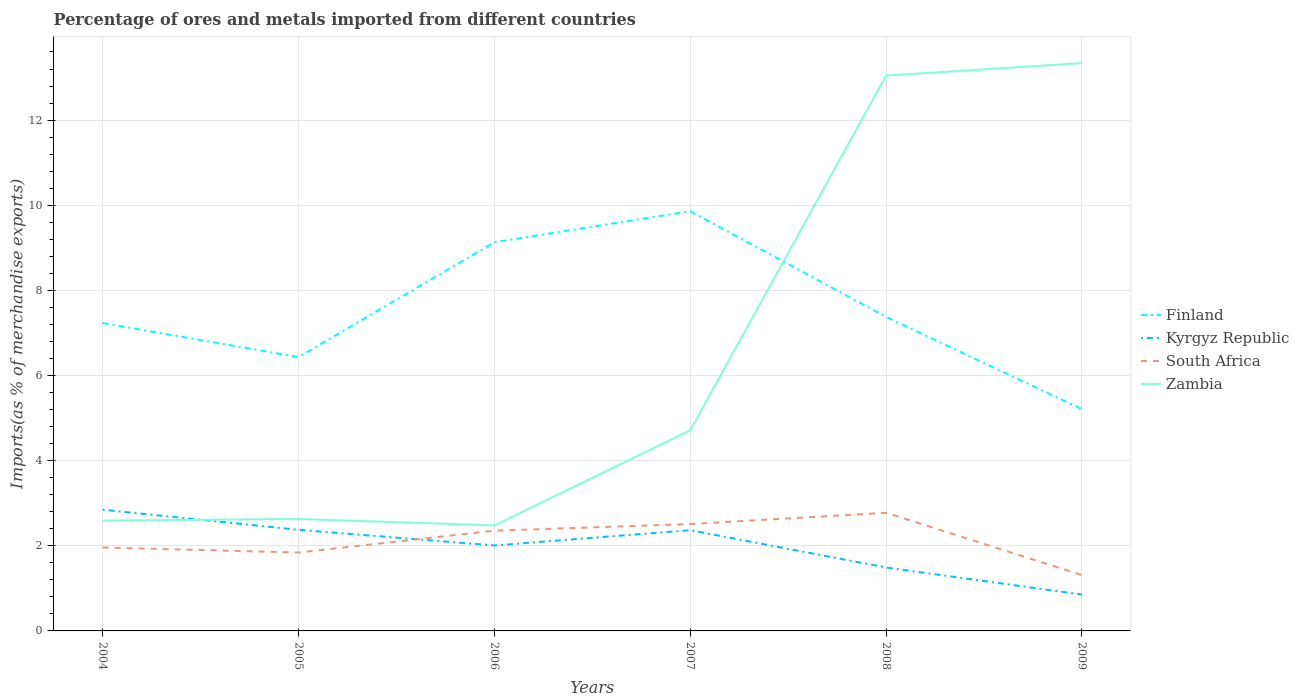Across all years, what is the maximum percentage of imports to different countries in Zambia?
Your answer should be very brief. 2.48. In which year was the percentage of imports to different countries in Kyrgyz Republic maximum?
Keep it short and to the point. 2009. What is the total percentage of imports to different countries in Zambia in the graph?
Your answer should be compact. -2.08. What is the difference between the highest and the second highest percentage of imports to different countries in Kyrgyz Republic?
Make the answer very short. 1.99. What is the difference between the highest and the lowest percentage of imports to different countries in South Africa?
Make the answer very short. 3. Is the percentage of imports to different countries in Finland strictly greater than the percentage of imports to different countries in Zambia over the years?
Give a very brief answer. No. How many lines are there?
Your answer should be very brief. 4. How many years are there in the graph?
Make the answer very short. 6. Are the values on the major ticks of Y-axis written in scientific E-notation?
Make the answer very short. No. How many legend labels are there?
Your response must be concise. 4. What is the title of the graph?
Your answer should be compact. Percentage of ores and metals imported from different countries. What is the label or title of the Y-axis?
Your response must be concise. Imports(as % of merchandise exports). What is the Imports(as % of merchandise exports) in Finland in 2004?
Provide a short and direct response. 7.23. What is the Imports(as % of merchandise exports) in Kyrgyz Republic in 2004?
Make the answer very short. 2.85. What is the Imports(as % of merchandise exports) of South Africa in 2004?
Ensure brevity in your answer.  1.96. What is the Imports(as % of merchandise exports) in Zambia in 2004?
Make the answer very short. 2.59. What is the Imports(as % of merchandise exports) of Finland in 2005?
Your answer should be compact. 6.43. What is the Imports(as % of merchandise exports) of Kyrgyz Republic in 2005?
Provide a short and direct response. 2.37. What is the Imports(as % of merchandise exports) in South Africa in 2005?
Offer a very short reply. 1.84. What is the Imports(as % of merchandise exports) of Zambia in 2005?
Provide a succinct answer. 2.63. What is the Imports(as % of merchandise exports) of Finland in 2006?
Your answer should be very brief. 9.13. What is the Imports(as % of merchandise exports) in Kyrgyz Republic in 2006?
Offer a terse response. 2.01. What is the Imports(as % of merchandise exports) in South Africa in 2006?
Keep it short and to the point. 2.35. What is the Imports(as % of merchandise exports) in Zambia in 2006?
Offer a terse response. 2.48. What is the Imports(as % of merchandise exports) of Finland in 2007?
Offer a very short reply. 9.86. What is the Imports(as % of merchandise exports) of Kyrgyz Republic in 2007?
Keep it short and to the point. 2.37. What is the Imports(as % of merchandise exports) of South Africa in 2007?
Offer a terse response. 2.51. What is the Imports(as % of merchandise exports) of Zambia in 2007?
Keep it short and to the point. 4.71. What is the Imports(as % of merchandise exports) of Finland in 2008?
Your answer should be compact. 7.38. What is the Imports(as % of merchandise exports) in Kyrgyz Republic in 2008?
Your response must be concise. 1.49. What is the Imports(as % of merchandise exports) in South Africa in 2008?
Your answer should be very brief. 2.78. What is the Imports(as % of merchandise exports) in Zambia in 2008?
Make the answer very short. 13.05. What is the Imports(as % of merchandise exports) of Finland in 2009?
Provide a succinct answer. 5.21. What is the Imports(as % of merchandise exports) in Kyrgyz Republic in 2009?
Your answer should be very brief. 0.85. What is the Imports(as % of merchandise exports) in South Africa in 2009?
Provide a short and direct response. 1.31. What is the Imports(as % of merchandise exports) of Zambia in 2009?
Your answer should be very brief. 13.34. Across all years, what is the maximum Imports(as % of merchandise exports) of Finland?
Provide a short and direct response. 9.86. Across all years, what is the maximum Imports(as % of merchandise exports) in Kyrgyz Republic?
Provide a succinct answer. 2.85. Across all years, what is the maximum Imports(as % of merchandise exports) in South Africa?
Keep it short and to the point. 2.78. Across all years, what is the maximum Imports(as % of merchandise exports) in Zambia?
Offer a terse response. 13.34. Across all years, what is the minimum Imports(as % of merchandise exports) of Finland?
Your response must be concise. 5.21. Across all years, what is the minimum Imports(as % of merchandise exports) in Kyrgyz Republic?
Make the answer very short. 0.85. Across all years, what is the minimum Imports(as % of merchandise exports) in South Africa?
Make the answer very short. 1.31. Across all years, what is the minimum Imports(as % of merchandise exports) of Zambia?
Your response must be concise. 2.48. What is the total Imports(as % of merchandise exports) of Finland in the graph?
Your answer should be very brief. 45.24. What is the total Imports(as % of merchandise exports) in Kyrgyz Republic in the graph?
Provide a succinct answer. 11.94. What is the total Imports(as % of merchandise exports) of South Africa in the graph?
Provide a short and direct response. 12.75. What is the total Imports(as % of merchandise exports) of Zambia in the graph?
Provide a short and direct response. 38.8. What is the difference between the Imports(as % of merchandise exports) of Finland in 2004 and that in 2005?
Make the answer very short. 0.8. What is the difference between the Imports(as % of merchandise exports) in Kyrgyz Republic in 2004 and that in 2005?
Offer a terse response. 0.47. What is the difference between the Imports(as % of merchandise exports) in South Africa in 2004 and that in 2005?
Keep it short and to the point. 0.12. What is the difference between the Imports(as % of merchandise exports) of Zambia in 2004 and that in 2005?
Provide a short and direct response. -0.04. What is the difference between the Imports(as % of merchandise exports) of Finland in 2004 and that in 2006?
Ensure brevity in your answer.  -1.9. What is the difference between the Imports(as % of merchandise exports) in Kyrgyz Republic in 2004 and that in 2006?
Keep it short and to the point. 0.84. What is the difference between the Imports(as % of merchandise exports) of South Africa in 2004 and that in 2006?
Your answer should be very brief. -0.4. What is the difference between the Imports(as % of merchandise exports) in Zambia in 2004 and that in 2006?
Your answer should be very brief. 0.11. What is the difference between the Imports(as % of merchandise exports) of Finland in 2004 and that in 2007?
Ensure brevity in your answer.  -2.63. What is the difference between the Imports(as % of merchandise exports) in Kyrgyz Republic in 2004 and that in 2007?
Provide a short and direct response. 0.48. What is the difference between the Imports(as % of merchandise exports) in South Africa in 2004 and that in 2007?
Your response must be concise. -0.55. What is the difference between the Imports(as % of merchandise exports) of Zambia in 2004 and that in 2007?
Your answer should be very brief. -2.12. What is the difference between the Imports(as % of merchandise exports) of Finland in 2004 and that in 2008?
Make the answer very short. -0.14. What is the difference between the Imports(as % of merchandise exports) in Kyrgyz Republic in 2004 and that in 2008?
Keep it short and to the point. 1.36. What is the difference between the Imports(as % of merchandise exports) of South Africa in 2004 and that in 2008?
Offer a terse response. -0.82. What is the difference between the Imports(as % of merchandise exports) of Zambia in 2004 and that in 2008?
Keep it short and to the point. -10.46. What is the difference between the Imports(as % of merchandise exports) of Finland in 2004 and that in 2009?
Offer a very short reply. 2.02. What is the difference between the Imports(as % of merchandise exports) in Kyrgyz Republic in 2004 and that in 2009?
Ensure brevity in your answer.  1.99. What is the difference between the Imports(as % of merchandise exports) of South Africa in 2004 and that in 2009?
Your response must be concise. 0.65. What is the difference between the Imports(as % of merchandise exports) of Zambia in 2004 and that in 2009?
Keep it short and to the point. -10.75. What is the difference between the Imports(as % of merchandise exports) in Finland in 2005 and that in 2006?
Your answer should be compact. -2.7. What is the difference between the Imports(as % of merchandise exports) of Kyrgyz Republic in 2005 and that in 2006?
Make the answer very short. 0.37. What is the difference between the Imports(as % of merchandise exports) in South Africa in 2005 and that in 2006?
Offer a terse response. -0.51. What is the difference between the Imports(as % of merchandise exports) in Zambia in 2005 and that in 2006?
Your answer should be compact. 0.15. What is the difference between the Imports(as % of merchandise exports) in Finland in 2005 and that in 2007?
Make the answer very short. -3.43. What is the difference between the Imports(as % of merchandise exports) of Kyrgyz Republic in 2005 and that in 2007?
Offer a terse response. 0.01. What is the difference between the Imports(as % of merchandise exports) of South Africa in 2005 and that in 2007?
Provide a succinct answer. -0.67. What is the difference between the Imports(as % of merchandise exports) in Zambia in 2005 and that in 2007?
Keep it short and to the point. -2.08. What is the difference between the Imports(as % of merchandise exports) of Finland in 2005 and that in 2008?
Make the answer very short. -0.94. What is the difference between the Imports(as % of merchandise exports) of Kyrgyz Republic in 2005 and that in 2008?
Offer a terse response. 0.89. What is the difference between the Imports(as % of merchandise exports) of South Africa in 2005 and that in 2008?
Ensure brevity in your answer.  -0.93. What is the difference between the Imports(as % of merchandise exports) in Zambia in 2005 and that in 2008?
Ensure brevity in your answer.  -10.42. What is the difference between the Imports(as % of merchandise exports) in Finland in 2005 and that in 2009?
Provide a succinct answer. 1.22. What is the difference between the Imports(as % of merchandise exports) of Kyrgyz Republic in 2005 and that in 2009?
Keep it short and to the point. 1.52. What is the difference between the Imports(as % of merchandise exports) of South Africa in 2005 and that in 2009?
Make the answer very short. 0.53. What is the difference between the Imports(as % of merchandise exports) in Zambia in 2005 and that in 2009?
Give a very brief answer. -10.71. What is the difference between the Imports(as % of merchandise exports) of Finland in 2006 and that in 2007?
Keep it short and to the point. -0.73. What is the difference between the Imports(as % of merchandise exports) of Kyrgyz Republic in 2006 and that in 2007?
Your answer should be very brief. -0.36. What is the difference between the Imports(as % of merchandise exports) of South Africa in 2006 and that in 2007?
Your answer should be compact. -0.16. What is the difference between the Imports(as % of merchandise exports) of Zambia in 2006 and that in 2007?
Provide a short and direct response. -2.23. What is the difference between the Imports(as % of merchandise exports) in Finland in 2006 and that in 2008?
Ensure brevity in your answer.  1.75. What is the difference between the Imports(as % of merchandise exports) in Kyrgyz Republic in 2006 and that in 2008?
Ensure brevity in your answer.  0.52. What is the difference between the Imports(as % of merchandise exports) of South Africa in 2006 and that in 2008?
Provide a short and direct response. -0.42. What is the difference between the Imports(as % of merchandise exports) of Zambia in 2006 and that in 2008?
Provide a succinct answer. -10.57. What is the difference between the Imports(as % of merchandise exports) in Finland in 2006 and that in 2009?
Your answer should be compact. 3.92. What is the difference between the Imports(as % of merchandise exports) of Kyrgyz Republic in 2006 and that in 2009?
Make the answer very short. 1.15. What is the difference between the Imports(as % of merchandise exports) of South Africa in 2006 and that in 2009?
Keep it short and to the point. 1.04. What is the difference between the Imports(as % of merchandise exports) in Zambia in 2006 and that in 2009?
Offer a very short reply. -10.86. What is the difference between the Imports(as % of merchandise exports) of Finland in 2007 and that in 2008?
Make the answer very short. 2.48. What is the difference between the Imports(as % of merchandise exports) of Kyrgyz Republic in 2007 and that in 2008?
Provide a short and direct response. 0.88. What is the difference between the Imports(as % of merchandise exports) in South Africa in 2007 and that in 2008?
Your response must be concise. -0.27. What is the difference between the Imports(as % of merchandise exports) of Zambia in 2007 and that in 2008?
Offer a very short reply. -8.33. What is the difference between the Imports(as % of merchandise exports) of Finland in 2007 and that in 2009?
Provide a succinct answer. 4.65. What is the difference between the Imports(as % of merchandise exports) in Kyrgyz Republic in 2007 and that in 2009?
Give a very brief answer. 1.51. What is the difference between the Imports(as % of merchandise exports) in South Africa in 2007 and that in 2009?
Your answer should be very brief. 1.2. What is the difference between the Imports(as % of merchandise exports) of Zambia in 2007 and that in 2009?
Provide a short and direct response. -8.63. What is the difference between the Imports(as % of merchandise exports) in Finland in 2008 and that in 2009?
Offer a terse response. 2.17. What is the difference between the Imports(as % of merchandise exports) of Kyrgyz Republic in 2008 and that in 2009?
Provide a short and direct response. 0.64. What is the difference between the Imports(as % of merchandise exports) in South Africa in 2008 and that in 2009?
Provide a short and direct response. 1.46. What is the difference between the Imports(as % of merchandise exports) of Zambia in 2008 and that in 2009?
Ensure brevity in your answer.  -0.29. What is the difference between the Imports(as % of merchandise exports) in Finland in 2004 and the Imports(as % of merchandise exports) in Kyrgyz Republic in 2005?
Your answer should be very brief. 4.86. What is the difference between the Imports(as % of merchandise exports) of Finland in 2004 and the Imports(as % of merchandise exports) of South Africa in 2005?
Provide a succinct answer. 5.39. What is the difference between the Imports(as % of merchandise exports) of Finland in 2004 and the Imports(as % of merchandise exports) of Zambia in 2005?
Make the answer very short. 4.6. What is the difference between the Imports(as % of merchandise exports) of Kyrgyz Republic in 2004 and the Imports(as % of merchandise exports) of Zambia in 2005?
Keep it short and to the point. 0.22. What is the difference between the Imports(as % of merchandise exports) of South Africa in 2004 and the Imports(as % of merchandise exports) of Zambia in 2005?
Offer a terse response. -0.67. What is the difference between the Imports(as % of merchandise exports) in Finland in 2004 and the Imports(as % of merchandise exports) in Kyrgyz Republic in 2006?
Ensure brevity in your answer.  5.22. What is the difference between the Imports(as % of merchandise exports) of Finland in 2004 and the Imports(as % of merchandise exports) of South Africa in 2006?
Keep it short and to the point. 4.88. What is the difference between the Imports(as % of merchandise exports) of Finland in 2004 and the Imports(as % of merchandise exports) of Zambia in 2006?
Your response must be concise. 4.75. What is the difference between the Imports(as % of merchandise exports) in Kyrgyz Republic in 2004 and the Imports(as % of merchandise exports) in South Africa in 2006?
Provide a succinct answer. 0.49. What is the difference between the Imports(as % of merchandise exports) of Kyrgyz Republic in 2004 and the Imports(as % of merchandise exports) of Zambia in 2006?
Offer a terse response. 0.37. What is the difference between the Imports(as % of merchandise exports) of South Africa in 2004 and the Imports(as % of merchandise exports) of Zambia in 2006?
Make the answer very short. -0.52. What is the difference between the Imports(as % of merchandise exports) in Finland in 2004 and the Imports(as % of merchandise exports) in Kyrgyz Republic in 2007?
Provide a succinct answer. 4.87. What is the difference between the Imports(as % of merchandise exports) in Finland in 2004 and the Imports(as % of merchandise exports) in South Africa in 2007?
Make the answer very short. 4.72. What is the difference between the Imports(as % of merchandise exports) of Finland in 2004 and the Imports(as % of merchandise exports) of Zambia in 2007?
Provide a short and direct response. 2.52. What is the difference between the Imports(as % of merchandise exports) in Kyrgyz Republic in 2004 and the Imports(as % of merchandise exports) in South Africa in 2007?
Make the answer very short. 0.34. What is the difference between the Imports(as % of merchandise exports) in Kyrgyz Republic in 2004 and the Imports(as % of merchandise exports) in Zambia in 2007?
Make the answer very short. -1.86. What is the difference between the Imports(as % of merchandise exports) of South Africa in 2004 and the Imports(as % of merchandise exports) of Zambia in 2007?
Your answer should be very brief. -2.75. What is the difference between the Imports(as % of merchandise exports) of Finland in 2004 and the Imports(as % of merchandise exports) of Kyrgyz Republic in 2008?
Make the answer very short. 5.74. What is the difference between the Imports(as % of merchandise exports) of Finland in 2004 and the Imports(as % of merchandise exports) of South Africa in 2008?
Give a very brief answer. 4.46. What is the difference between the Imports(as % of merchandise exports) in Finland in 2004 and the Imports(as % of merchandise exports) in Zambia in 2008?
Your response must be concise. -5.81. What is the difference between the Imports(as % of merchandise exports) in Kyrgyz Republic in 2004 and the Imports(as % of merchandise exports) in South Africa in 2008?
Offer a very short reply. 0.07. What is the difference between the Imports(as % of merchandise exports) of Kyrgyz Republic in 2004 and the Imports(as % of merchandise exports) of Zambia in 2008?
Offer a very short reply. -10.2. What is the difference between the Imports(as % of merchandise exports) of South Africa in 2004 and the Imports(as % of merchandise exports) of Zambia in 2008?
Keep it short and to the point. -11.09. What is the difference between the Imports(as % of merchandise exports) in Finland in 2004 and the Imports(as % of merchandise exports) in Kyrgyz Republic in 2009?
Give a very brief answer. 6.38. What is the difference between the Imports(as % of merchandise exports) in Finland in 2004 and the Imports(as % of merchandise exports) in South Africa in 2009?
Ensure brevity in your answer.  5.92. What is the difference between the Imports(as % of merchandise exports) of Finland in 2004 and the Imports(as % of merchandise exports) of Zambia in 2009?
Provide a succinct answer. -6.11. What is the difference between the Imports(as % of merchandise exports) in Kyrgyz Republic in 2004 and the Imports(as % of merchandise exports) in South Africa in 2009?
Offer a very short reply. 1.54. What is the difference between the Imports(as % of merchandise exports) of Kyrgyz Republic in 2004 and the Imports(as % of merchandise exports) of Zambia in 2009?
Make the answer very short. -10.49. What is the difference between the Imports(as % of merchandise exports) in South Africa in 2004 and the Imports(as % of merchandise exports) in Zambia in 2009?
Give a very brief answer. -11.38. What is the difference between the Imports(as % of merchandise exports) of Finland in 2005 and the Imports(as % of merchandise exports) of Kyrgyz Republic in 2006?
Make the answer very short. 4.43. What is the difference between the Imports(as % of merchandise exports) of Finland in 2005 and the Imports(as % of merchandise exports) of South Africa in 2006?
Offer a terse response. 4.08. What is the difference between the Imports(as % of merchandise exports) of Finland in 2005 and the Imports(as % of merchandise exports) of Zambia in 2006?
Your answer should be compact. 3.95. What is the difference between the Imports(as % of merchandise exports) of Kyrgyz Republic in 2005 and the Imports(as % of merchandise exports) of South Africa in 2006?
Offer a very short reply. 0.02. What is the difference between the Imports(as % of merchandise exports) in Kyrgyz Republic in 2005 and the Imports(as % of merchandise exports) in Zambia in 2006?
Keep it short and to the point. -0.1. What is the difference between the Imports(as % of merchandise exports) in South Africa in 2005 and the Imports(as % of merchandise exports) in Zambia in 2006?
Provide a succinct answer. -0.64. What is the difference between the Imports(as % of merchandise exports) of Finland in 2005 and the Imports(as % of merchandise exports) of Kyrgyz Republic in 2007?
Offer a terse response. 4.07. What is the difference between the Imports(as % of merchandise exports) of Finland in 2005 and the Imports(as % of merchandise exports) of South Africa in 2007?
Provide a short and direct response. 3.92. What is the difference between the Imports(as % of merchandise exports) of Finland in 2005 and the Imports(as % of merchandise exports) of Zambia in 2007?
Provide a short and direct response. 1.72. What is the difference between the Imports(as % of merchandise exports) in Kyrgyz Republic in 2005 and the Imports(as % of merchandise exports) in South Africa in 2007?
Your answer should be compact. -0.14. What is the difference between the Imports(as % of merchandise exports) in Kyrgyz Republic in 2005 and the Imports(as % of merchandise exports) in Zambia in 2007?
Provide a succinct answer. -2.34. What is the difference between the Imports(as % of merchandise exports) in South Africa in 2005 and the Imports(as % of merchandise exports) in Zambia in 2007?
Make the answer very short. -2.87. What is the difference between the Imports(as % of merchandise exports) of Finland in 2005 and the Imports(as % of merchandise exports) of Kyrgyz Republic in 2008?
Offer a very short reply. 4.94. What is the difference between the Imports(as % of merchandise exports) in Finland in 2005 and the Imports(as % of merchandise exports) in South Africa in 2008?
Ensure brevity in your answer.  3.66. What is the difference between the Imports(as % of merchandise exports) of Finland in 2005 and the Imports(as % of merchandise exports) of Zambia in 2008?
Offer a very short reply. -6.61. What is the difference between the Imports(as % of merchandise exports) of Kyrgyz Republic in 2005 and the Imports(as % of merchandise exports) of South Africa in 2008?
Your answer should be compact. -0.4. What is the difference between the Imports(as % of merchandise exports) in Kyrgyz Republic in 2005 and the Imports(as % of merchandise exports) in Zambia in 2008?
Provide a succinct answer. -10.67. What is the difference between the Imports(as % of merchandise exports) of South Africa in 2005 and the Imports(as % of merchandise exports) of Zambia in 2008?
Offer a terse response. -11.2. What is the difference between the Imports(as % of merchandise exports) in Finland in 2005 and the Imports(as % of merchandise exports) in Kyrgyz Republic in 2009?
Offer a terse response. 5.58. What is the difference between the Imports(as % of merchandise exports) of Finland in 2005 and the Imports(as % of merchandise exports) of South Africa in 2009?
Provide a short and direct response. 5.12. What is the difference between the Imports(as % of merchandise exports) in Finland in 2005 and the Imports(as % of merchandise exports) in Zambia in 2009?
Make the answer very short. -6.9. What is the difference between the Imports(as % of merchandise exports) in Kyrgyz Republic in 2005 and the Imports(as % of merchandise exports) in South Africa in 2009?
Your response must be concise. 1.06. What is the difference between the Imports(as % of merchandise exports) in Kyrgyz Republic in 2005 and the Imports(as % of merchandise exports) in Zambia in 2009?
Offer a terse response. -10.96. What is the difference between the Imports(as % of merchandise exports) in South Africa in 2005 and the Imports(as % of merchandise exports) in Zambia in 2009?
Provide a short and direct response. -11.5. What is the difference between the Imports(as % of merchandise exports) in Finland in 2006 and the Imports(as % of merchandise exports) in Kyrgyz Republic in 2007?
Your response must be concise. 6.76. What is the difference between the Imports(as % of merchandise exports) of Finland in 2006 and the Imports(as % of merchandise exports) of South Africa in 2007?
Provide a short and direct response. 6.62. What is the difference between the Imports(as % of merchandise exports) of Finland in 2006 and the Imports(as % of merchandise exports) of Zambia in 2007?
Offer a terse response. 4.42. What is the difference between the Imports(as % of merchandise exports) of Kyrgyz Republic in 2006 and the Imports(as % of merchandise exports) of South Africa in 2007?
Provide a succinct answer. -0.5. What is the difference between the Imports(as % of merchandise exports) of Kyrgyz Republic in 2006 and the Imports(as % of merchandise exports) of Zambia in 2007?
Give a very brief answer. -2.7. What is the difference between the Imports(as % of merchandise exports) of South Africa in 2006 and the Imports(as % of merchandise exports) of Zambia in 2007?
Provide a short and direct response. -2.36. What is the difference between the Imports(as % of merchandise exports) in Finland in 2006 and the Imports(as % of merchandise exports) in Kyrgyz Republic in 2008?
Offer a terse response. 7.64. What is the difference between the Imports(as % of merchandise exports) of Finland in 2006 and the Imports(as % of merchandise exports) of South Africa in 2008?
Provide a succinct answer. 6.36. What is the difference between the Imports(as % of merchandise exports) in Finland in 2006 and the Imports(as % of merchandise exports) in Zambia in 2008?
Offer a very short reply. -3.91. What is the difference between the Imports(as % of merchandise exports) in Kyrgyz Republic in 2006 and the Imports(as % of merchandise exports) in South Africa in 2008?
Offer a terse response. -0.77. What is the difference between the Imports(as % of merchandise exports) of Kyrgyz Republic in 2006 and the Imports(as % of merchandise exports) of Zambia in 2008?
Ensure brevity in your answer.  -11.04. What is the difference between the Imports(as % of merchandise exports) in South Africa in 2006 and the Imports(as % of merchandise exports) in Zambia in 2008?
Your answer should be very brief. -10.69. What is the difference between the Imports(as % of merchandise exports) of Finland in 2006 and the Imports(as % of merchandise exports) of Kyrgyz Republic in 2009?
Offer a terse response. 8.28. What is the difference between the Imports(as % of merchandise exports) of Finland in 2006 and the Imports(as % of merchandise exports) of South Africa in 2009?
Make the answer very short. 7.82. What is the difference between the Imports(as % of merchandise exports) of Finland in 2006 and the Imports(as % of merchandise exports) of Zambia in 2009?
Your answer should be compact. -4.21. What is the difference between the Imports(as % of merchandise exports) of Kyrgyz Republic in 2006 and the Imports(as % of merchandise exports) of South Africa in 2009?
Provide a short and direct response. 0.7. What is the difference between the Imports(as % of merchandise exports) in Kyrgyz Republic in 2006 and the Imports(as % of merchandise exports) in Zambia in 2009?
Your answer should be compact. -11.33. What is the difference between the Imports(as % of merchandise exports) in South Africa in 2006 and the Imports(as % of merchandise exports) in Zambia in 2009?
Ensure brevity in your answer.  -10.98. What is the difference between the Imports(as % of merchandise exports) of Finland in 2007 and the Imports(as % of merchandise exports) of Kyrgyz Republic in 2008?
Provide a short and direct response. 8.37. What is the difference between the Imports(as % of merchandise exports) of Finland in 2007 and the Imports(as % of merchandise exports) of South Africa in 2008?
Provide a short and direct response. 7.08. What is the difference between the Imports(as % of merchandise exports) in Finland in 2007 and the Imports(as % of merchandise exports) in Zambia in 2008?
Keep it short and to the point. -3.19. What is the difference between the Imports(as % of merchandise exports) of Kyrgyz Republic in 2007 and the Imports(as % of merchandise exports) of South Africa in 2008?
Offer a very short reply. -0.41. What is the difference between the Imports(as % of merchandise exports) of Kyrgyz Republic in 2007 and the Imports(as % of merchandise exports) of Zambia in 2008?
Your answer should be compact. -10.68. What is the difference between the Imports(as % of merchandise exports) in South Africa in 2007 and the Imports(as % of merchandise exports) in Zambia in 2008?
Give a very brief answer. -10.54. What is the difference between the Imports(as % of merchandise exports) of Finland in 2007 and the Imports(as % of merchandise exports) of Kyrgyz Republic in 2009?
Offer a terse response. 9.01. What is the difference between the Imports(as % of merchandise exports) of Finland in 2007 and the Imports(as % of merchandise exports) of South Africa in 2009?
Provide a succinct answer. 8.55. What is the difference between the Imports(as % of merchandise exports) in Finland in 2007 and the Imports(as % of merchandise exports) in Zambia in 2009?
Provide a short and direct response. -3.48. What is the difference between the Imports(as % of merchandise exports) of Kyrgyz Republic in 2007 and the Imports(as % of merchandise exports) of South Africa in 2009?
Provide a succinct answer. 1.05. What is the difference between the Imports(as % of merchandise exports) of Kyrgyz Republic in 2007 and the Imports(as % of merchandise exports) of Zambia in 2009?
Offer a very short reply. -10.97. What is the difference between the Imports(as % of merchandise exports) of South Africa in 2007 and the Imports(as % of merchandise exports) of Zambia in 2009?
Your response must be concise. -10.83. What is the difference between the Imports(as % of merchandise exports) in Finland in 2008 and the Imports(as % of merchandise exports) in Kyrgyz Republic in 2009?
Keep it short and to the point. 6.52. What is the difference between the Imports(as % of merchandise exports) of Finland in 2008 and the Imports(as % of merchandise exports) of South Africa in 2009?
Your answer should be very brief. 6.06. What is the difference between the Imports(as % of merchandise exports) in Finland in 2008 and the Imports(as % of merchandise exports) in Zambia in 2009?
Your response must be concise. -5.96. What is the difference between the Imports(as % of merchandise exports) of Kyrgyz Republic in 2008 and the Imports(as % of merchandise exports) of South Africa in 2009?
Make the answer very short. 0.18. What is the difference between the Imports(as % of merchandise exports) in Kyrgyz Republic in 2008 and the Imports(as % of merchandise exports) in Zambia in 2009?
Your response must be concise. -11.85. What is the difference between the Imports(as % of merchandise exports) in South Africa in 2008 and the Imports(as % of merchandise exports) in Zambia in 2009?
Provide a succinct answer. -10.56. What is the average Imports(as % of merchandise exports) in Finland per year?
Give a very brief answer. 7.54. What is the average Imports(as % of merchandise exports) of Kyrgyz Republic per year?
Make the answer very short. 1.99. What is the average Imports(as % of merchandise exports) in South Africa per year?
Your answer should be very brief. 2.13. What is the average Imports(as % of merchandise exports) of Zambia per year?
Your answer should be compact. 6.47. In the year 2004, what is the difference between the Imports(as % of merchandise exports) in Finland and Imports(as % of merchandise exports) in Kyrgyz Republic?
Offer a very short reply. 4.38. In the year 2004, what is the difference between the Imports(as % of merchandise exports) in Finland and Imports(as % of merchandise exports) in South Africa?
Your answer should be very brief. 5.27. In the year 2004, what is the difference between the Imports(as % of merchandise exports) of Finland and Imports(as % of merchandise exports) of Zambia?
Ensure brevity in your answer.  4.64. In the year 2004, what is the difference between the Imports(as % of merchandise exports) in Kyrgyz Republic and Imports(as % of merchandise exports) in South Africa?
Make the answer very short. 0.89. In the year 2004, what is the difference between the Imports(as % of merchandise exports) in Kyrgyz Republic and Imports(as % of merchandise exports) in Zambia?
Your response must be concise. 0.26. In the year 2004, what is the difference between the Imports(as % of merchandise exports) in South Africa and Imports(as % of merchandise exports) in Zambia?
Your answer should be compact. -0.63. In the year 2005, what is the difference between the Imports(as % of merchandise exports) of Finland and Imports(as % of merchandise exports) of Kyrgyz Republic?
Your response must be concise. 4.06. In the year 2005, what is the difference between the Imports(as % of merchandise exports) in Finland and Imports(as % of merchandise exports) in South Africa?
Keep it short and to the point. 4.59. In the year 2005, what is the difference between the Imports(as % of merchandise exports) of Finland and Imports(as % of merchandise exports) of Zambia?
Your answer should be compact. 3.8. In the year 2005, what is the difference between the Imports(as % of merchandise exports) of Kyrgyz Republic and Imports(as % of merchandise exports) of South Africa?
Give a very brief answer. 0.53. In the year 2005, what is the difference between the Imports(as % of merchandise exports) in Kyrgyz Republic and Imports(as % of merchandise exports) in Zambia?
Offer a terse response. -0.26. In the year 2005, what is the difference between the Imports(as % of merchandise exports) in South Africa and Imports(as % of merchandise exports) in Zambia?
Your answer should be very brief. -0.79. In the year 2006, what is the difference between the Imports(as % of merchandise exports) in Finland and Imports(as % of merchandise exports) in Kyrgyz Republic?
Make the answer very short. 7.12. In the year 2006, what is the difference between the Imports(as % of merchandise exports) of Finland and Imports(as % of merchandise exports) of South Africa?
Offer a terse response. 6.78. In the year 2006, what is the difference between the Imports(as % of merchandise exports) in Finland and Imports(as % of merchandise exports) in Zambia?
Keep it short and to the point. 6.65. In the year 2006, what is the difference between the Imports(as % of merchandise exports) of Kyrgyz Republic and Imports(as % of merchandise exports) of South Africa?
Provide a short and direct response. -0.35. In the year 2006, what is the difference between the Imports(as % of merchandise exports) of Kyrgyz Republic and Imports(as % of merchandise exports) of Zambia?
Provide a succinct answer. -0.47. In the year 2006, what is the difference between the Imports(as % of merchandise exports) in South Africa and Imports(as % of merchandise exports) in Zambia?
Provide a succinct answer. -0.12. In the year 2007, what is the difference between the Imports(as % of merchandise exports) of Finland and Imports(as % of merchandise exports) of Kyrgyz Republic?
Provide a short and direct response. 7.49. In the year 2007, what is the difference between the Imports(as % of merchandise exports) in Finland and Imports(as % of merchandise exports) in South Africa?
Make the answer very short. 7.35. In the year 2007, what is the difference between the Imports(as % of merchandise exports) in Finland and Imports(as % of merchandise exports) in Zambia?
Ensure brevity in your answer.  5.15. In the year 2007, what is the difference between the Imports(as % of merchandise exports) of Kyrgyz Republic and Imports(as % of merchandise exports) of South Africa?
Offer a terse response. -0.14. In the year 2007, what is the difference between the Imports(as % of merchandise exports) of Kyrgyz Republic and Imports(as % of merchandise exports) of Zambia?
Your answer should be very brief. -2.35. In the year 2007, what is the difference between the Imports(as % of merchandise exports) in South Africa and Imports(as % of merchandise exports) in Zambia?
Offer a terse response. -2.2. In the year 2008, what is the difference between the Imports(as % of merchandise exports) of Finland and Imports(as % of merchandise exports) of Kyrgyz Republic?
Your answer should be compact. 5.89. In the year 2008, what is the difference between the Imports(as % of merchandise exports) in Finland and Imports(as % of merchandise exports) in South Africa?
Provide a succinct answer. 4.6. In the year 2008, what is the difference between the Imports(as % of merchandise exports) in Finland and Imports(as % of merchandise exports) in Zambia?
Your answer should be compact. -5.67. In the year 2008, what is the difference between the Imports(as % of merchandise exports) of Kyrgyz Republic and Imports(as % of merchandise exports) of South Africa?
Keep it short and to the point. -1.29. In the year 2008, what is the difference between the Imports(as % of merchandise exports) in Kyrgyz Republic and Imports(as % of merchandise exports) in Zambia?
Your answer should be very brief. -11.56. In the year 2008, what is the difference between the Imports(as % of merchandise exports) in South Africa and Imports(as % of merchandise exports) in Zambia?
Keep it short and to the point. -10.27. In the year 2009, what is the difference between the Imports(as % of merchandise exports) in Finland and Imports(as % of merchandise exports) in Kyrgyz Republic?
Your response must be concise. 4.36. In the year 2009, what is the difference between the Imports(as % of merchandise exports) of Finland and Imports(as % of merchandise exports) of South Africa?
Your answer should be compact. 3.9. In the year 2009, what is the difference between the Imports(as % of merchandise exports) in Finland and Imports(as % of merchandise exports) in Zambia?
Offer a very short reply. -8.13. In the year 2009, what is the difference between the Imports(as % of merchandise exports) in Kyrgyz Republic and Imports(as % of merchandise exports) in South Africa?
Your answer should be very brief. -0.46. In the year 2009, what is the difference between the Imports(as % of merchandise exports) in Kyrgyz Republic and Imports(as % of merchandise exports) in Zambia?
Your answer should be very brief. -12.48. In the year 2009, what is the difference between the Imports(as % of merchandise exports) of South Africa and Imports(as % of merchandise exports) of Zambia?
Make the answer very short. -12.03. What is the ratio of the Imports(as % of merchandise exports) of Finland in 2004 to that in 2005?
Keep it short and to the point. 1.12. What is the ratio of the Imports(as % of merchandise exports) of Kyrgyz Republic in 2004 to that in 2005?
Provide a succinct answer. 1.2. What is the ratio of the Imports(as % of merchandise exports) of South Africa in 2004 to that in 2005?
Make the answer very short. 1.06. What is the ratio of the Imports(as % of merchandise exports) of Finland in 2004 to that in 2006?
Give a very brief answer. 0.79. What is the ratio of the Imports(as % of merchandise exports) in Kyrgyz Republic in 2004 to that in 2006?
Provide a succinct answer. 1.42. What is the ratio of the Imports(as % of merchandise exports) in South Africa in 2004 to that in 2006?
Your answer should be compact. 0.83. What is the ratio of the Imports(as % of merchandise exports) of Zambia in 2004 to that in 2006?
Provide a short and direct response. 1.05. What is the ratio of the Imports(as % of merchandise exports) in Finland in 2004 to that in 2007?
Your answer should be very brief. 0.73. What is the ratio of the Imports(as % of merchandise exports) of Kyrgyz Republic in 2004 to that in 2007?
Offer a terse response. 1.2. What is the ratio of the Imports(as % of merchandise exports) of South Africa in 2004 to that in 2007?
Give a very brief answer. 0.78. What is the ratio of the Imports(as % of merchandise exports) of Zambia in 2004 to that in 2007?
Offer a terse response. 0.55. What is the ratio of the Imports(as % of merchandise exports) of Finland in 2004 to that in 2008?
Your answer should be compact. 0.98. What is the ratio of the Imports(as % of merchandise exports) of Kyrgyz Republic in 2004 to that in 2008?
Provide a short and direct response. 1.91. What is the ratio of the Imports(as % of merchandise exports) in South Africa in 2004 to that in 2008?
Give a very brief answer. 0.71. What is the ratio of the Imports(as % of merchandise exports) in Zambia in 2004 to that in 2008?
Ensure brevity in your answer.  0.2. What is the ratio of the Imports(as % of merchandise exports) in Finland in 2004 to that in 2009?
Give a very brief answer. 1.39. What is the ratio of the Imports(as % of merchandise exports) in Kyrgyz Republic in 2004 to that in 2009?
Offer a very short reply. 3.33. What is the ratio of the Imports(as % of merchandise exports) in South Africa in 2004 to that in 2009?
Ensure brevity in your answer.  1.49. What is the ratio of the Imports(as % of merchandise exports) of Zambia in 2004 to that in 2009?
Your answer should be compact. 0.19. What is the ratio of the Imports(as % of merchandise exports) in Finland in 2005 to that in 2006?
Offer a very short reply. 0.7. What is the ratio of the Imports(as % of merchandise exports) of Kyrgyz Republic in 2005 to that in 2006?
Keep it short and to the point. 1.18. What is the ratio of the Imports(as % of merchandise exports) of South Africa in 2005 to that in 2006?
Offer a terse response. 0.78. What is the ratio of the Imports(as % of merchandise exports) in Zambia in 2005 to that in 2006?
Provide a short and direct response. 1.06. What is the ratio of the Imports(as % of merchandise exports) of Finland in 2005 to that in 2007?
Keep it short and to the point. 0.65. What is the ratio of the Imports(as % of merchandise exports) of Kyrgyz Republic in 2005 to that in 2007?
Ensure brevity in your answer.  1. What is the ratio of the Imports(as % of merchandise exports) in South Africa in 2005 to that in 2007?
Provide a succinct answer. 0.73. What is the ratio of the Imports(as % of merchandise exports) in Zambia in 2005 to that in 2007?
Offer a very short reply. 0.56. What is the ratio of the Imports(as % of merchandise exports) in Finland in 2005 to that in 2008?
Your answer should be very brief. 0.87. What is the ratio of the Imports(as % of merchandise exports) of Kyrgyz Republic in 2005 to that in 2008?
Your response must be concise. 1.59. What is the ratio of the Imports(as % of merchandise exports) in South Africa in 2005 to that in 2008?
Ensure brevity in your answer.  0.66. What is the ratio of the Imports(as % of merchandise exports) of Zambia in 2005 to that in 2008?
Provide a succinct answer. 0.2. What is the ratio of the Imports(as % of merchandise exports) in Finland in 2005 to that in 2009?
Give a very brief answer. 1.23. What is the ratio of the Imports(as % of merchandise exports) of Kyrgyz Republic in 2005 to that in 2009?
Give a very brief answer. 2.78. What is the ratio of the Imports(as % of merchandise exports) in South Africa in 2005 to that in 2009?
Give a very brief answer. 1.4. What is the ratio of the Imports(as % of merchandise exports) of Zambia in 2005 to that in 2009?
Offer a terse response. 0.2. What is the ratio of the Imports(as % of merchandise exports) in Finland in 2006 to that in 2007?
Make the answer very short. 0.93. What is the ratio of the Imports(as % of merchandise exports) of Kyrgyz Republic in 2006 to that in 2007?
Your answer should be compact. 0.85. What is the ratio of the Imports(as % of merchandise exports) in South Africa in 2006 to that in 2007?
Give a very brief answer. 0.94. What is the ratio of the Imports(as % of merchandise exports) of Zambia in 2006 to that in 2007?
Provide a short and direct response. 0.53. What is the ratio of the Imports(as % of merchandise exports) in Finland in 2006 to that in 2008?
Give a very brief answer. 1.24. What is the ratio of the Imports(as % of merchandise exports) of Kyrgyz Republic in 2006 to that in 2008?
Offer a terse response. 1.35. What is the ratio of the Imports(as % of merchandise exports) of South Africa in 2006 to that in 2008?
Give a very brief answer. 0.85. What is the ratio of the Imports(as % of merchandise exports) in Zambia in 2006 to that in 2008?
Offer a terse response. 0.19. What is the ratio of the Imports(as % of merchandise exports) in Finland in 2006 to that in 2009?
Make the answer very short. 1.75. What is the ratio of the Imports(as % of merchandise exports) of Kyrgyz Republic in 2006 to that in 2009?
Provide a succinct answer. 2.35. What is the ratio of the Imports(as % of merchandise exports) of South Africa in 2006 to that in 2009?
Make the answer very short. 1.79. What is the ratio of the Imports(as % of merchandise exports) of Zambia in 2006 to that in 2009?
Provide a succinct answer. 0.19. What is the ratio of the Imports(as % of merchandise exports) of Finland in 2007 to that in 2008?
Provide a succinct answer. 1.34. What is the ratio of the Imports(as % of merchandise exports) of Kyrgyz Republic in 2007 to that in 2008?
Give a very brief answer. 1.59. What is the ratio of the Imports(as % of merchandise exports) of South Africa in 2007 to that in 2008?
Keep it short and to the point. 0.9. What is the ratio of the Imports(as % of merchandise exports) in Zambia in 2007 to that in 2008?
Make the answer very short. 0.36. What is the ratio of the Imports(as % of merchandise exports) in Finland in 2007 to that in 2009?
Provide a short and direct response. 1.89. What is the ratio of the Imports(as % of merchandise exports) of Kyrgyz Republic in 2007 to that in 2009?
Your answer should be compact. 2.77. What is the ratio of the Imports(as % of merchandise exports) of South Africa in 2007 to that in 2009?
Your answer should be very brief. 1.91. What is the ratio of the Imports(as % of merchandise exports) of Zambia in 2007 to that in 2009?
Keep it short and to the point. 0.35. What is the ratio of the Imports(as % of merchandise exports) of Finland in 2008 to that in 2009?
Your answer should be very brief. 1.42. What is the ratio of the Imports(as % of merchandise exports) in Kyrgyz Republic in 2008 to that in 2009?
Your answer should be compact. 1.74. What is the ratio of the Imports(as % of merchandise exports) in South Africa in 2008 to that in 2009?
Provide a short and direct response. 2.12. What is the ratio of the Imports(as % of merchandise exports) in Zambia in 2008 to that in 2009?
Give a very brief answer. 0.98. What is the difference between the highest and the second highest Imports(as % of merchandise exports) in Finland?
Your response must be concise. 0.73. What is the difference between the highest and the second highest Imports(as % of merchandise exports) in Kyrgyz Republic?
Your answer should be compact. 0.47. What is the difference between the highest and the second highest Imports(as % of merchandise exports) in South Africa?
Provide a succinct answer. 0.27. What is the difference between the highest and the second highest Imports(as % of merchandise exports) in Zambia?
Your response must be concise. 0.29. What is the difference between the highest and the lowest Imports(as % of merchandise exports) in Finland?
Your response must be concise. 4.65. What is the difference between the highest and the lowest Imports(as % of merchandise exports) of Kyrgyz Republic?
Your response must be concise. 1.99. What is the difference between the highest and the lowest Imports(as % of merchandise exports) of South Africa?
Give a very brief answer. 1.46. What is the difference between the highest and the lowest Imports(as % of merchandise exports) in Zambia?
Ensure brevity in your answer.  10.86. 